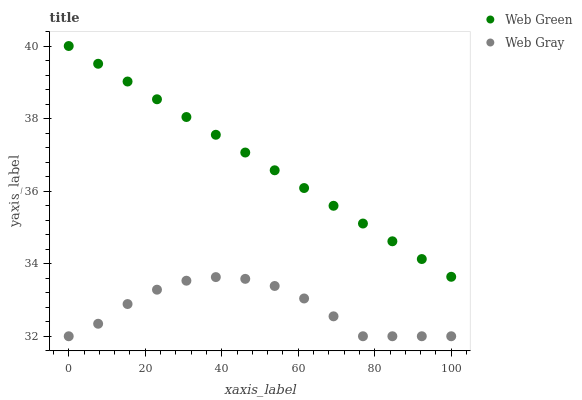Does Web Gray have the minimum area under the curve?
Answer yes or no. Yes. Does Web Green have the maximum area under the curve?
Answer yes or no. Yes. Does Web Green have the minimum area under the curve?
Answer yes or no. No. Is Web Green the smoothest?
Answer yes or no. Yes. Is Web Gray the roughest?
Answer yes or no. Yes. Is Web Green the roughest?
Answer yes or no. No. Does Web Gray have the lowest value?
Answer yes or no. Yes. Does Web Green have the lowest value?
Answer yes or no. No. Does Web Green have the highest value?
Answer yes or no. Yes. Is Web Gray less than Web Green?
Answer yes or no. Yes. Is Web Green greater than Web Gray?
Answer yes or no. Yes. Does Web Gray intersect Web Green?
Answer yes or no. No. 